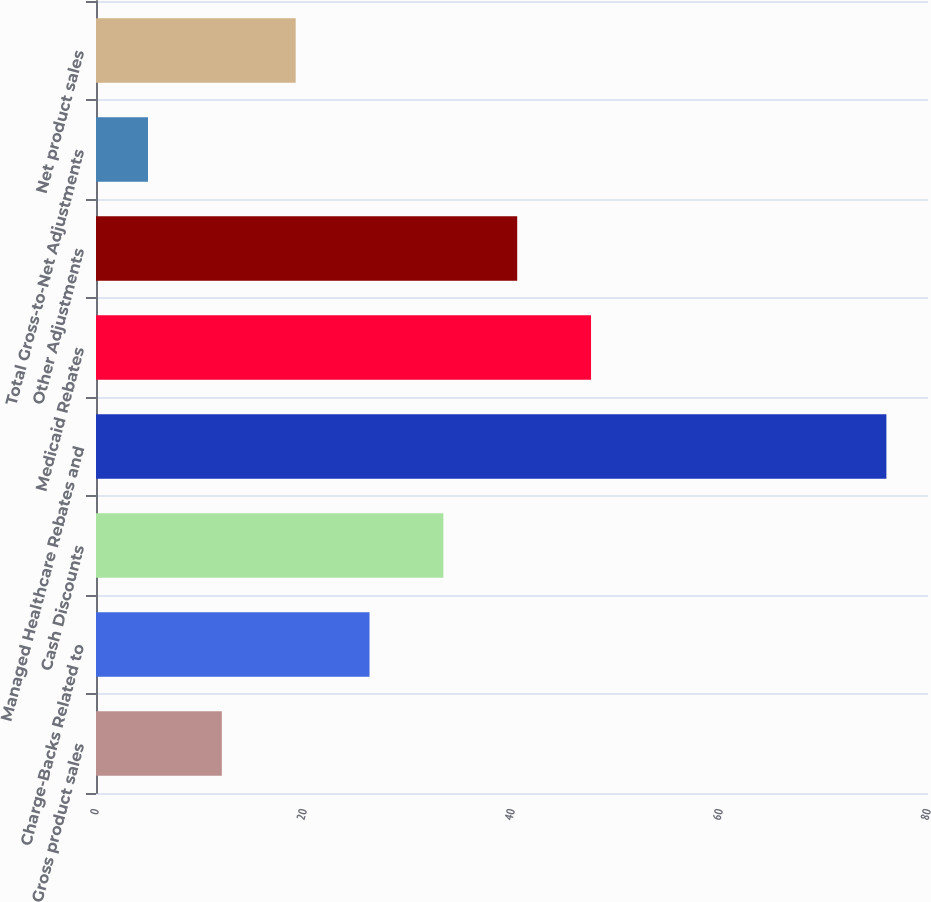<chart> <loc_0><loc_0><loc_500><loc_500><bar_chart><fcel>Gross product sales<fcel>Charge-Backs Related to<fcel>Cash Discounts<fcel>Managed Healthcare Rebates and<fcel>Medicaid Rebates<fcel>Other Adjustments<fcel>Total Gross-to-Net Adjustments<fcel>Net product sales<nl><fcel>12.1<fcel>26.3<fcel>33.4<fcel>76<fcel>47.6<fcel>40.5<fcel>5<fcel>19.2<nl></chart> 